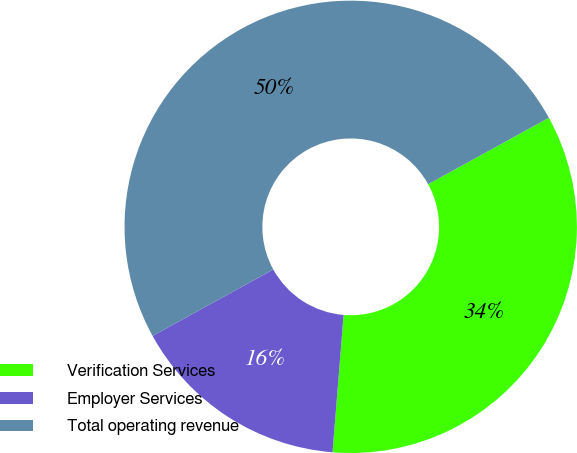<chart> <loc_0><loc_0><loc_500><loc_500><pie_chart><fcel>Verification Services<fcel>Employer Services<fcel>Total operating revenue<nl><fcel>34.29%<fcel>15.71%<fcel>50.0%<nl></chart> 